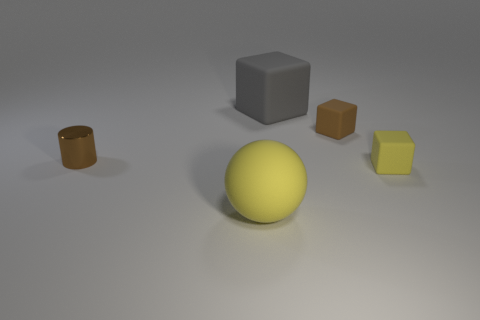What number of cyan objects are metal cylinders or small blocks? In the image, there are no cyan objects; hence, there are zero metal cylinders or small blocks that are cyan. 